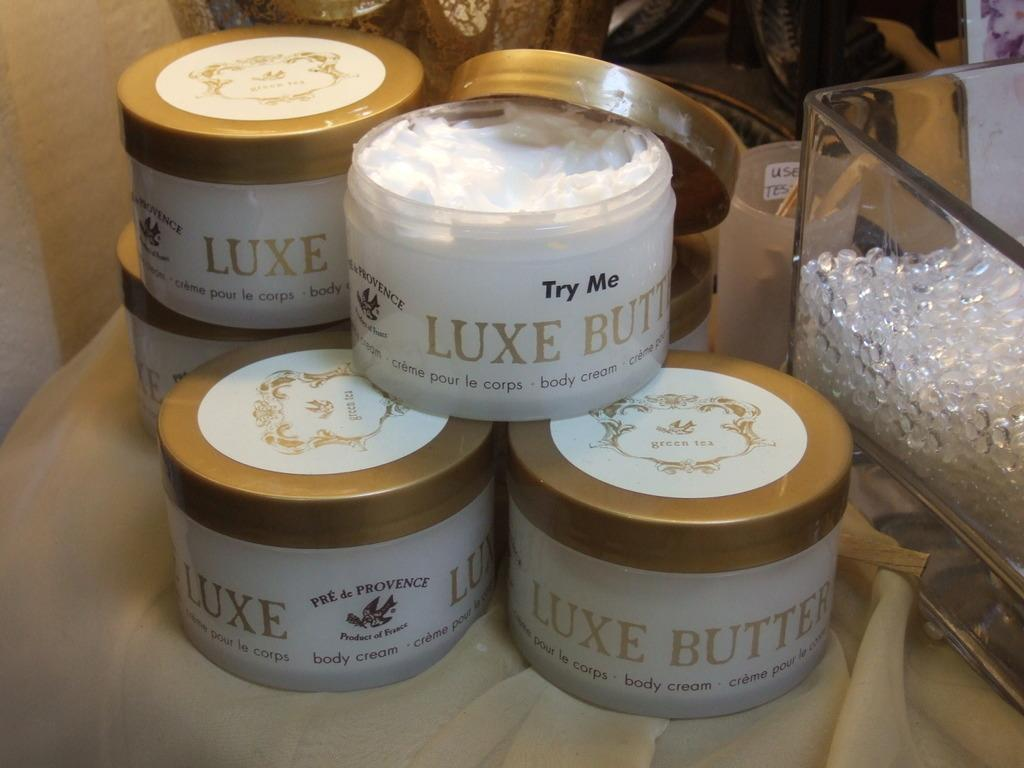What objects are present on the table in the image? There are boxes and a glass box on the table in the image. What is unique about the glass box? The glass box is made of glass, which makes it transparent. What type of furniture is visible at the top of the image? There is a couch visible at the top of the image. What can be seen on the wall on the left side of the image? There is a light beam on the wall on the left side of the image. What type of trousers is the family wearing in the image? There is no family present in the image, and therefore, no one is wearing trousers. What shape is the couch in the image? The provided facts do not mention the shape of the couch, so we cannot determine its shape from the information given. 